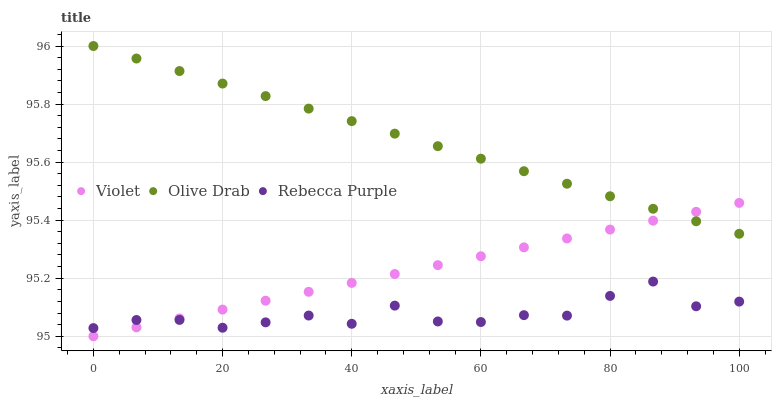Does Rebecca Purple have the minimum area under the curve?
Answer yes or no. Yes. Does Olive Drab have the maximum area under the curve?
Answer yes or no. Yes. Does Violet have the minimum area under the curve?
Answer yes or no. No. Does Violet have the maximum area under the curve?
Answer yes or no. No. Is Violet the smoothest?
Answer yes or no. Yes. Is Rebecca Purple the roughest?
Answer yes or no. Yes. Is Olive Drab the smoothest?
Answer yes or no. No. Is Olive Drab the roughest?
Answer yes or no. No. Does Violet have the lowest value?
Answer yes or no. Yes. Does Olive Drab have the lowest value?
Answer yes or no. No. Does Olive Drab have the highest value?
Answer yes or no. Yes. Does Violet have the highest value?
Answer yes or no. No. Is Rebecca Purple less than Olive Drab?
Answer yes or no. Yes. Is Olive Drab greater than Rebecca Purple?
Answer yes or no. Yes. Does Rebecca Purple intersect Violet?
Answer yes or no. Yes. Is Rebecca Purple less than Violet?
Answer yes or no. No. Is Rebecca Purple greater than Violet?
Answer yes or no. No. Does Rebecca Purple intersect Olive Drab?
Answer yes or no. No. 